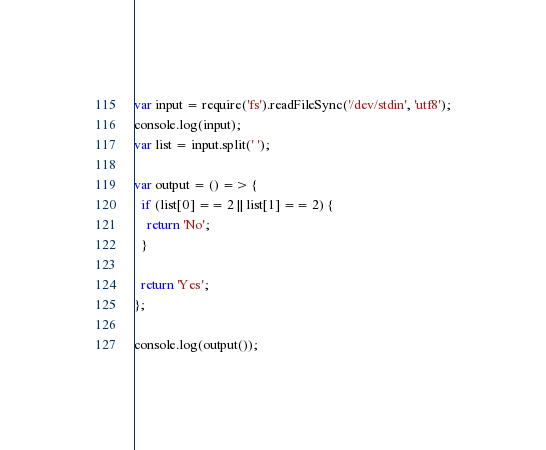<code> <loc_0><loc_0><loc_500><loc_500><_JavaScript_>var input = require('fs').readFileSync('/dev/stdin', 'utf8');
console.log(input);
var list = input.split(' ');

var output = () => {
  if (list[0] == 2 || list[1] == 2) {
    return 'No';
  }

  return 'Yes';
};

console.log(output());
</code> 